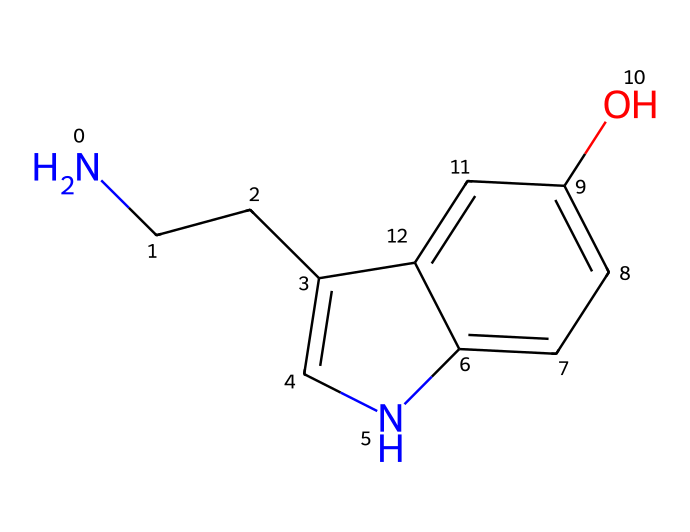What is the molecular formula for serotonin? To derive the molecular formula, we analyze the SMILES representation. Counting the elements from the structure, we identify 10 carbon atoms (C), 12 hydrogen atoms (H), 2 nitrogen atoms (N), and 1 oxygen atom (O). Thus, the molecular formula is assembled as C10H12N2O.
Answer: C10H12N2O How many nitrogen atoms are present in serotonin? By breaking down the components of the SMILES representation, we can identify the nitrogen atoms denoted by the letter 'N'. There are two instances of 'N' present.
Answer: 2 What type of functional group does serotonin contain? Examining the structure, we observe an -OH (hydroxyl) group attached to the benzene ring. This identifies serotonin as having a phenolic hydroxyl functional group.
Answer: hydroxyl What is the significance of the indole moiety in serotonin? The indole moiety, present in the structure of serotonin, is crucial as it contributes to serotonin's role as a neurotransmitter in the brain. This cyclic structure enhances its ability to interact with serotonin receptors.
Answer: neurotransmitter How many rings are present in the serotonin structure? On examining the SMILES representation, we see that there is one cyclic structure formed by the indole group and an additional fused ring structure in the molecule. Therefore, there are two rings present in the serotonin structure.
Answer: 2 What property is primarily influenced by the nitrogen atoms in serotonin? The nitrogen atoms in serotonin contribute to its basicity and ability to form hydrogen bonds. This affects serotonin's solubility in water and its interactions with receptors.
Answer: basicity 